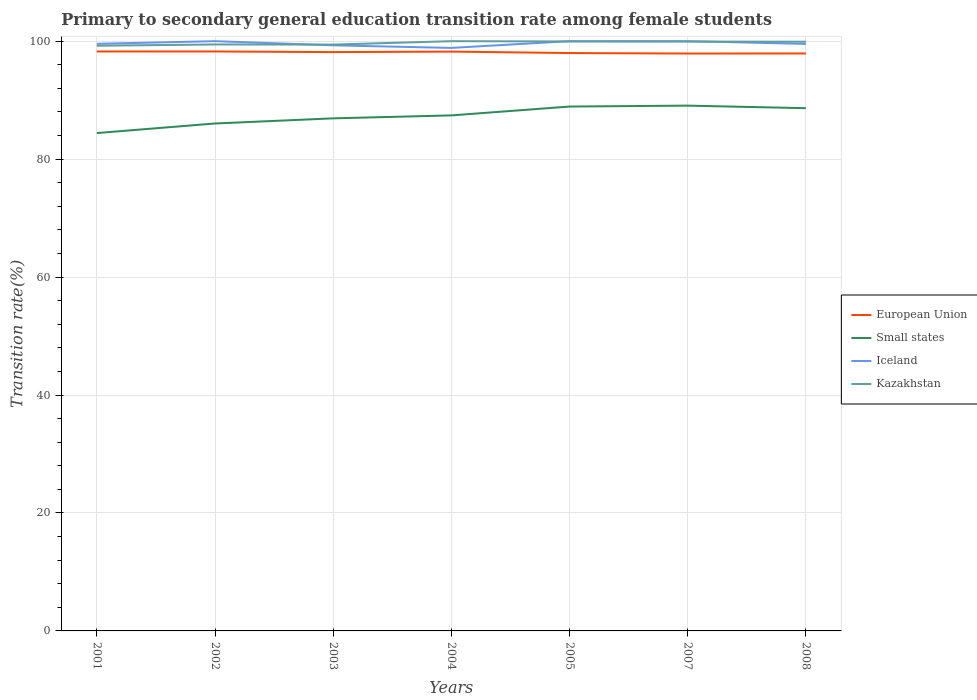How many different coloured lines are there?
Provide a succinct answer. 4. Does the line corresponding to Iceland intersect with the line corresponding to Small states?
Your answer should be very brief. No. Is the number of lines equal to the number of legend labels?
Provide a short and direct response. Yes. Across all years, what is the maximum transition rate in Kazakhstan?
Your answer should be compact. 99.23. In which year was the transition rate in Small states maximum?
Make the answer very short. 2001. What is the total transition rate in European Union in the graph?
Keep it short and to the point. 0.02. What is the difference between the highest and the second highest transition rate in European Union?
Keep it short and to the point. 0.35. What is the difference between the highest and the lowest transition rate in Iceland?
Give a very brief answer. 3. Are the values on the major ticks of Y-axis written in scientific E-notation?
Your response must be concise. No. Does the graph contain any zero values?
Offer a very short reply. No. Does the graph contain grids?
Give a very brief answer. Yes. How many legend labels are there?
Your response must be concise. 4. How are the legend labels stacked?
Provide a succinct answer. Vertical. What is the title of the graph?
Give a very brief answer. Primary to secondary general education transition rate among female students. Does "Palau" appear as one of the legend labels in the graph?
Your answer should be very brief. No. What is the label or title of the Y-axis?
Your response must be concise. Transition rate(%). What is the Transition rate(%) of European Union in 2001?
Provide a succinct answer. 98.25. What is the Transition rate(%) of Small states in 2001?
Keep it short and to the point. 84.42. What is the Transition rate(%) in Iceland in 2001?
Give a very brief answer. 99.55. What is the Transition rate(%) of Kazakhstan in 2001?
Give a very brief answer. 99.23. What is the Transition rate(%) of European Union in 2002?
Offer a terse response. 98.26. What is the Transition rate(%) of Small states in 2002?
Give a very brief answer. 86.04. What is the Transition rate(%) in Iceland in 2002?
Your answer should be very brief. 100. What is the Transition rate(%) in Kazakhstan in 2002?
Offer a very short reply. 99.44. What is the Transition rate(%) in European Union in 2003?
Give a very brief answer. 98.15. What is the Transition rate(%) of Small states in 2003?
Ensure brevity in your answer.  86.92. What is the Transition rate(%) in Iceland in 2003?
Offer a terse response. 99.29. What is the Transition rate(%) in Kazakhstan in 2003?
Your answer should be very brief. 99.42. What is the Transition rate(%) of European Union in 2004?
Ensure brevity in your answer.  98.23. What is the Transition rate(%) of Small states in 2004?
Keep it short and to the point. 87.41. What is the Transition rate(%) of Iceland in 2004?
Your answer should be very brief. 98.86. What is the Transition rate(%) in European Union in 2005?
Give a very brief answer. 97.99. What is the Transition rate(%) in Small states in 2005?
Offer a very short reply. 88.91. What is the Transition rate(%) of Iceland in 2005?
Make the answer very short. 100. What is the Transition rate(%) of Kazakhstan in 2005?
Give a very brief answer. 99.95. What is the Transition rate(%) in European Union in 2007?
Your answer should be very brief. 97.9. What is the Transition rate(%) in Small states in 2007?
Provide a succinct answer. 89.07. What is the Transition rate(%) in Iceland in 2007?
Offer a very short reply. 100. What is the Transition rate(%) in Kazakhstan in 2007?
Make the answer very short. 99.93. What is the Transition rate(%) in European Union in 2008?
Make the answer very short. 97.92. What is the Transition rate(%) in Small states in 2008?
Offer a very short reply. 88.64. What is the Transition rate(%) of Iceland in 2008?
Offer a terse response. 99.54. What is the Transition rate(%) of Kazakhstan in 2008?
Give a very brief answer. 99.91. Across all years, what is the maximum Transition rate(%) in European Union?
Give a very brief answer. 98.26. Across all years, what is the maximum Transition rate(%) in Small states?
Provide a succinct answer. 89.07. Across all years, what is the maximum Transition rate(%) in Kazakhstan?
Your answer should be compact. 100. Across all years, what is the minimum Transition rate(%) of European Union?
Keep it short and to the point. 97.9. Across all years, what is the minimum Transition rate(%) of Small states?
Make the answer very short. 84.42. Across all years, what is the minimum Transition rate(%) of Iceland?
Make the answer very short. 98.86. Across all years, what is the minimum Transition rate(%) of Kazakhstan?
Offer a terse response. 99.23. What is the total Transition rate(%) of European Union in the graph?
Provide a short and direct response. 686.69. What is the total Transition rate(%) of Small states in the graph?
Keep it short and to the point. 611.41. What is the total Transition rate(%) of Iceland in the graph?
Provide a short and direct response. 697.24. What is the total Transition rate(%) in Kazakhstan in the graph?
Your answer should be very brief. 697.88. What is the difference between the Transition rate(%) in European Union in 2001 and that in 2002?
Your answer should be compact. -0. What is the difference between the Transition rate(%) in Small states in 2001 and that in 2002?
Provide a succinct answer. -1.62. What is the difference between the Transition rate(%) of Iceland in 2001 and that in 2002?
Keep it short and to the point. -0.45. What is the difference between the Transition rate(%) of Kazakhstan in 2001 and that in 2002?
Provide a short and direct response. -0.21. What is the difference between the Transition rate(%) in European Union in 2001 and that in 2003?
Ensure brevity in your answer.  0.11. What is the difference between the Transition rate(%) in Small states in 2001 and that in 2003?
Make the answer very short. -2.5. What is the difference between the Transition rate(%) in Iceland in 2001 and that in 2003?
Your answer should be compact. 0.25. What is the difference between the Transition rate(%) in Kazakhstan in 2001 and that in 2003?
Provide a succinct answer. -0.19. What is the difference between the Transition rate(%) of European Union in 2001 and that in 2004?
Your response must be concise. 0.02. What is the difference between the Transition rate(%) of Small states in 2001 and that in 2004?
Make the answer very short. -2.99. What is the difference between the Transition rate(%) of Iceland in 2001 and that in 2004?
Your response must be concise. 0.69. What is the difference between the Transition rate(%) in Kazakhstan in 2001 and that in 2004?
Provide a short and direct response. -0.77. What is the difference between the Transition rate(%) in European Union in 2001 and that in 2005?
Your answer should be very brief. 0.27. What is the difference between the Transition rate(%) of Small states in 2001 and that in 2005?
Your answer should be compact. -4.5. What is the difference between the Transition rate(%) in Iceland in 2001 and that in 2005?
Ensure brevity in your answer.  -0.45. What is the difference between the Transition rate(%) of Kazakhstan in 2001 and that in 2005?
Your answer should be very brief. -0.72. What is the difference between the Transition rate(%) in European Union in 2001 and that in 2007?
Keep it short and to the point. 0.35. What is the difference between the Transition rate(%) of Small states in 2001 and that in 2007?
Your answer should be very brief. -4.65. What is the difference between the Transition rate(%) in Iceland in 2001 and that in 2007?
Your response must be concise. -0.45. What is the difference between the Transition rate(%) in Kazakhstan in 2001 and that in 2007?
Give a very brief answer. -0.7. What is the difference between the Transition rate(%) in European Union in 2001 and that in 2008?
Offer a very short reply. 0.34. What is the difference between the Transition rate(%) in Small states in 2001 and that in 2008?
Make the answer very short. -4.22. What is the difference between the Transition rate(%) of Iceland in 2001 and that in 2008?
Give a very brief answer. 0.01. What is the difference between the Transition rate(%) of Kazakhstan in 2001 and that in 2008?
Your answer should be very brief. -0.68. What is the difference between the Transition rate(%) of European Union in 2002 and that in 2003?
Provide a short and direct response. 0.11. What is the difference between the Transition rate(%) of Small states in 2002 and that in 2003?
Give a very brief answer. -0.87. What is the difference between the Transition rate(%) in Iceland in 2002 and that in 2003?
Make the answer very short. 0.71. What is the difference between the Transition rate(%) of Kazakhstan in 2002 and that in 2003?
Your answer should be very brief. 0.02. What is the difference between the Transition rate(%) of European Union in 2002 and that in 2004?
Provide a short and direct response. 0.02. What is the difference between the Transition rate(%) in Small states in 2002 and that in 2004?
Offer a very short reply. -1.37. What is the difference between the Transition rate(%) of Iceland in 2002 and that in 2004?
Keep it short and to the point. 1.14. What is the difference between the Transition rate(%) of Kazakhstan in 2002 and that in 2004?
Your answer should be very brief. -0.56. What is the difference between the Transition rate(%) in European Union in 2002 and that in 2005?
Provide a short and direct response. 0.27. What is the difference between the Transition rate(%) in Small states in 2002 and that in 2005?
Provide a short and direct response. -2.87. What is the difference between the Transition rate(%) of Iceland in 2002 and that in 2005?
Your answer should be compact. 0. What is the difference between the Transition rate(%) of Kazakhstan in 2002 and that in 2005?
Keep it short and to the point. -0.51. What is the difference between the Transition rate(%) of European Union in 2002 and that in 2007?
Your answer should be compact. 0.35. What is the difference between the Transition rate(%) in Small states in 2002 and that in 2007?
Give a very brief answer. -3.03. What is the difference between the Transition rate(%) in Kazakhstan in 2002 and that in 2007?
Provide a succinct answer. -0.49. What is the difference between the Transition rate(%) of European Union in 2002 and that in 2008?
Offer a terse response. 0.34. What is the difference between the Transition rate(%) of Small states in 2002 and that in 2008?
Keep it short and to the point. -2.59. What is the difference between the Transition rate(%) of Iceland in 2002 and that in 2008?
Offer a terse response. 0.46. What is the difference between the Transition rate(%) of Kazakhstan in 2002 and that in 2008?
Your answer should be compact. -0.47. What is the difference between the Transition rate(%) in European Union in 2003 and that in 2004?
Your response must be concise. -0.09. What is the difference between the Transition rate(%) in Small states in 2003 and that in 2004?
Your answer should be compact. -0.5. What is the difference between the Transition rate(%) of Iceland in 2003 and that in 2004?
Give a very brief answer. 0.44. What is the difference between the Transition rate(%) of Kazakhstan in 2003 and that in 2004?
Your answer should be very brief. -0.58. What is the difference between the Transition rate(%) of European Union in 2003 and that in 2005?
Keep it short and to the point. 0.16. What is the difference between the Transition rate(%) in Small states in 2003 and that in 2005?
Give a very brief answer. -2. What is the difference between the Transition rate(%) in Iceland in 2003 and that in 2005?
Offer a very short reply. -0.71. What is the difference between the Transition rate(%) of Kazakhstan in 2003 and that in 2005?
Offer a terse response. -0.53. What is the difference between the Transition rate(%) in European Union in 2003 and that in 2007?
Provide a succinct answer. 0.24. What is the difference between the Transition rate(%) in Small states in 2003 and that in 2007?
Your answer should be compact. -2.16. What is the difference between the Transition rate(%) in Iceland in 2003 and that in 2007?
Provide a succinct answer. -0.71. What is the difference between the Transition rate(%) in Kazakhstan in 2003 and that in 2007?
Offer a terse response. -0.51. What is the difference between the Transition rate(%) of European Union in 2003 and that in 2008?
Ensure brevity in your answer.  0.23. What is the difference between the Transition rate(%) in Small states in 2003 and that in 2008?
Ensure brevity in your answer.  -1.72. What is the difference between the Transition rate(%) of Iceland in 2003 and that in 2008?
Your answer should be very brief. -0.24. What is the difference between the Transition rate(%) of Kazakhstan in 2003 and that in 2008?
Your response must be concise. -0.49. What is the difference between the Transition rate(%) in European Union in 2004 and that in 2005?
Offer a terse response. 0.25. What is the difference between the Transition rate(%) in Small states in 2004 and that in 2005?
Offer a very short reply. -1.5. What is the difference between the Transition rate(%) of Iceland in 2004 and that in 2005?
Your answer should be compact. -1.14. What is the difference between the Transition rate(%) of Kazakhstan in 2004 and that in 2005?
Offer a terse response. 0.05. What is the difference between the Transition rate(%) in European Union in 2004 and that in 2007?
Offer a terse response. 0.33. What is the difference between the Transition rate(%) of Small states in 2004 and that in 2007?
Keep it short and to the point. -1.66. What is the difference between the Transition rate(%) of Iceland in 2004 and that in 2007?
Give a very brief answer. -1.14. What is the difference between the Transition rate(%) in Kazakhstan in 2004 and that in 2007?
Provide a succinct answer. 0.07. What is the difference between the Transition rate(%) in European Union in 2004 and that in 2008?
Provide a short and direct response. 0.32. What is the difference between the Transition rate(%) of Small states in 2004 and that in 2008?
Provide a short and direct response. -1.22. What is the difference between the Transition rate(%) in Iceland in 2004 and that in 2008?
Give a very brief answer. -0.68. What is the difference between the Transition rate(%) in Kazakhstan in 2004 and that in 2008?
Provide a succinct answer. 0.09. What is the difference between the Transition rate(%) in European Union in 2005 and that in 2007?
Offer a terse response. 0.08. What is the difference between the Transition rate(%) in Small states in 2005 and that in 2007?
Your response must be concise. -0.16. What is the difference between the Transition rate(%) of Iceland in 2005 and that in 2007?
Your response must be concise. 0. What is the difference between the Transition rate(%) in Kazakhstan in 2005 and that in 2007?
Ensure brevity in your answer.  0.02. What is the difference between the Transition rate(%) in European Union in 2005 and that in 2008?
Give a very brief answer. 0.07. What is the difference between the Transition rate(%) in Small states in 2005 and that in 2008?
Offer a very short reply. 0.28. What is the difference between the Transition rate(%) in Iceland in 2005 and that in 2008?
Your answer should be compact. 0.46. What is the difference between the Transition rate(%) in Kazakhstan in 2005 and that in 2008?
Offer a very short reply. 0.05. What is the difference between the Transition rate(%) in European Union in 2007 and that in 2008?
Your answer should be very brief. -0.01. What is the difference between the Transition rate(%) of Small states in 2007 and that in 2008?
Your response must be concise. 0.43. What is the difference between the Transition rate(%) in Iceland in 2007 and that in 2008?
Your answer should be very brief. 0.46. What is the difference between the Transition rate(%) of Kazakhstan in 2007 and that in 2008?
Keep it short and to the point. 0.03. What is the difference between the Transition rate(%) in European Union in 2001 and the Transition rate(%) in Small states in 2002?
Provide a short and direct response. 12.21. What is the difference between the Transition rate(%) in European Union in 2001 and the Transition rate(%) in Iceland in 2002?
Your answer should be very brief. -1.75. What is the difference between the Transition rate(%) in European Union in 2001 and the Transition rate(%) in Kazakhstan in 2002?
Provide a succinct answer. -1.19. What is the difference between the Transition rate(%) in Small states in 2001 and the Transition rate(%) in Iceland in 2002?
Give a very brief answer. -15.58. What is the difference between the Transition rate(%) in Small states in 2001 and the Transition rate(%) in Kazakhstan in 2002?
Your answer should be compact. -15.02. What is the difference between the Transition rate(%) in Iceland in 2001 and the Transition rate(%) in Kazakhstan in 2002?
Ensure brevity in your answer.  0.11. What is the difference between the Transition rate(%) of European Union in 2001 and the Transition rate(%) of Small states in 2003?
Provide a succinct answer. 11.34. What is the difference between the Transition rate(%) in European Union in 2001 and the Transition rate(%) in Iceland in 2003?
Your answer should be compact. -1.04. What is the difference between the Transition rate(%) in European Union in 2001 and the Transition rate(%) in Kazakhstan in 2003?
Offer a terse response. -1.17. What is the difference between the Transition rate(%) in Small states in 2001 and the Transition rate(%) in Iceland in 2003?
Ensure brevity in your answer.  -14.88. What is the difference between the Transition rate(%) in Small states in 2001 and the Transition rate(%) in Kazakhstan in 2003?
Provide a succinct answer. -15. What is the difference between the Transition rate(%) in Iceland in 2001 and the Transition rate(%) in Kazakhstan in 2003?
Make the answer very short. 0.13. What is the difference between the Transition rate(%) in European Union in 2001 and the Transition rate(%) in Small states in 2004?
Your answer should be very brief. 10.84. What is the difference between the Transition rate(%) in European Union in 2001 and the Transition rate(%) in Iceland in 2004?
Give a very brief answer. -0.6. What is the difference between the Transition rate(%) in European Union in 2001 and the Transition rate(%) in Kazakhstan in 2004?
Give a very brief answer. -1.75. What is the difference between the Transition rate(%) of Small states in 2001 and the Transition rate(%) of Iceland in 2004?
Your response must be concise. -14.44. What is the difference between the Transition rate(%) in Small states in 2001 and the Transition rate(%) in Kazakhstan in 2004?
Offer a terse response. -15.58. What is the difference between the Transition rate(%) of Iceland in 2001 and the Transition rate(%) of Kazakhstan in 2004?
Your answer should be very brief. -0.45. What is the difference between the Transition rate(%) of European Union in 2001 and the Transition rate(%) of Small states in 2005?
Your response must be concise. 9.34. What is the difference between the Transition rate(%) in European Union in 2001 and the Transition rate(%) in Iceland in 2005?
Provide a succinct answer. -1.75. What is the difference between the Transition rate(%) in European Union in 2001 and the Transition rate(%) in Kazakhstan in 2005?
Your answer should be very brief. -1.7. What is the difference between the Transition rate(%) in Small states in 2001 and the Transition rate(%) in Iceland in 2005?
Offer a terse response. -15.58. What is the difference between the Transition rate(%) of Small states in 2001 and the Transition rate(%) of Kazakhstan in 2005?
Your answer should be very brief. -15.53. What is the difference between the Transition rate(%) of Iceland in 2001 and the Transition rate(%) of Kazakhstan in 2005?
Ensure brevity in your answer.  -0.4. What is the difference between the Transition rate(%) in European Union in 2001 and the Transition rate(%) in Small states in 2007?
Offer a very short reply. 9.18. What is the difference between the Transition rate(%) of European Union in 2001 and the Transition rate(%) of Iceland in 2007?
Your answer should be very brief. -1.75. What is the difference between the Transition rate(%) in European Union in 2001 and the Transition rate(%) in Kazakhstan in 2007?
Ensure brevity in your answer.  -1.68. What is the difference between the Transition rate(%) in Small states in 2001 and the Transition rate(%) in Iceland in 2007?
Your answer should be compact. -15.58. What is the difference between the Transition rate(%) in Small states in 2001 and the Transition rate(%) in Kazakhstan in 2007?
Offer a very short reply. -15.51. What is the difference between the Transition rate(%) of Iceland in 2001 and the Transition rate(%) of Kazakhstan in 2007?
Your answer should be very brief. -0.38. What is the difference between the Transition rate(%) of European Union in 2001 and the Transition rate(%) of Small states in 2008?
Offer a very short reply. 9.62. What is the difference between the Transition rate(%) in European Union in 2001 and the Transition rate(%) in Iceland in 2008?
Provide a succinct answer. -1.29. What is the difference between the Transition rate(%) of European Union in 2001 and the Transition rate(%) of Kazakhstan in 2008?
Provide a short and direct response. -1.65. What is the difference between the Transition rate(%) in Small states in 2001 and the Transition rate(%) in Iceland in 2008?
Give a very brief answer. -15.12. What is the difference between the Transition rate(%) of Small states in 2001 and the Transition rate(%) of Kazakhstan in 2008?
Offer a terse response. -15.49. What is the difference between the Transition rate(%) of Iceland in 2001 and the Transition rate(%) of Kazakhstan in 2008?
Provide a succinct answer. -0.36. What is the difference between the Transition rate(%) in European Union in 2002 and the Transition rate(%) in Small states in 2003?
Make the answer very short. 11.34. What is the difference between the Transition rate(%) of European Union in 2002 and the Transition rate(%) of Iceland in 2003?
Keep it short and to the point. -1.04. What is the difference between the Transition rate(%) in European Union in 2002 and the Transition rate(%) in Kazakhstan in 2003?
Your answer should be very brief. -1.17. What is the difference between the Transition rate(%) of Small states in 2002 and the Transition rate(%) of Iceland in 2003?
Provide a succinct answer. -13.25. What is the difference between the Transition rate(%) in Small states in 2002 and the Transition rate(%) in Kazakhstan in 2003?
Offer a very short reply. -13.38. What is the difference between the Transition rate(%) in Iceland in 2002 and the Transition rate(%) in Kazakhstan in 2003?
Your answer should be very brief. 0.58. What is the difference between the Transition rate(%) of European Union in 2002 and the Transition rate(%) of Small states in 2004?
Offer a terse response. 10.84. What is the difference between the Transition rate(%) of European Union in 2002 and the Transition rate(%) of Iceland in 2004?
Ensure brevity in your answer.  -0.6. What is the difference between the Transition rate(%) in European Union in 2002 and the Transition rate(%) in Kazakhstan in 2004?
Your answer should be compact. -1.74. What is the difference between the Transition rate(%) of Small states in 2002 and the Transition rate(%) of Iceland in 2004?
Give a very brief answer. -12.81. What is the difference between the Transition rate(%) of Small states in 2002 and the Transition rate(%) of Kazakhstan in 2004?
Your answer should be compact. -13.96. What is the difference between the Transition rate(%) of European Union in 2002 and the Transition rate(%) of Small states in 2005?
Your answer should be compact. 9.34. What is the difference between the Transition rate(%) in European Union in 2002 and the Transition rate(%) in Iceland in 2005?
Provide a short and direct response. -1.74. What is the difference between the Transition rate(%) of European Union in 2002 and the Transition rate(%) of Kazakhstan in 2005?
Keep it short and to the point. -1.7. What is the difference between the Transition rate(%) of Small states in 2002 and the Transition rate(%) of Iceland in 2005?
Your response must be concise. -13.96. What is the difference between the Transition rate(%) of Small states in 2002 and the Transition rate(%) of Kazakhstan in 2005?
Offer a terse response. -13.91. What is the difference between the Transition rate(%) of Iceland in 2002 and the Transition rate(%) of Kazakhstan in 2005?
Make the answer very short. 0.05. What is the difference between the Transition rate(%) of European Union in 2002 and the Transition rate(%) of Small states in 2007?
Your answer should be very brief. 9.18. What is the difference between the Transition rate(%) in European Union in 2002 and the Transition rate(%) in Iceland in 2007?
Your answer should be compact. -1.74. What is the difference between the Transition rate(%) in European Union in 2002 and the Transition rate(%) in Kazakhstan in 2007?
Provide a short and direct response. -1.68. What is the difference between the Transition rate(%) of Small states in 2002 and the Transition rate(%) of Iceland in 2007?
Give a very brief answer. -13.96. What is the difference between the Transition rate(%) of Small states in 2002 and the Transition rate(%) of Kazakhstan in 2007?
Make the answer very short. -13.89. What is the difference between the Transition rate(%) of Iceland in 2002 and the Transition rate(%) of Kazakhstan in 2007?
Your response must be concise. 0.07. What is the difference between the Transition rate(%) in European Union in 2002 and the Transition rate(%) in Small states in 2008?
Give a very brief answer. 9.62. What is the difference between the Transition rate(%) of European Union in 2002 and the Transition rate(%) of Iceland in 2008?
Offer a very short reply. -1.28. What is the difference between the Transition rate(%) of European Union in 2002 and the Transition rate(%) of Kazakhstan in 2008?
Offer a very short reply. -1.65. What is the difference between the Transition rate(%) in Small states in 2002 and the Transition rate(%) in Iceland in 2008?
Provide a short and direct response. -13.5. What is the difference between the Transition rate(%) of Small states in 2002 and the Transition rate(%) of Kazakhstan in 2008?
Offer a very short reply. -13.86. What is the difference between the Transition rate(%) in Iceland in 2002 and the Transition rate(%) in Kazakhstan in 2008?
Ensure brevity in your answer.  0.09. What is the difference between the Transition rate(%) of European Union in 2003 and the Transition rate(%) of Small states in 2004?
Give a very brief answer. 10.73. What is the difference between the Transition rate(%) in European Union in 2003 and the Transition rate(%) in Iceland in 2004?
Offer a very short reply. -0.71. What is the difference between the Transition rate(%) in European Union in 2003 and the Transition rate(%) in Kazakhstan in 2004?
Offer a very short reply. -1.85. What is the difference between the Transition rate(%) in Small states in 2003 and the Transition rate(%) in Iceland in 2004?
Your response must be concise. -11.94. What is the difference between the Transition rate(%) in Small states in 2003 and the Transition rate(%) in Kazakhstan in 2004?
Provide a succinct answer. -13.08. What is the difference between the Transition rate(%) in Iceland in 2003 and the Transition rate(%) in Kazakhstan in 2004?
Your answer should be very brief. -0.71. What is the difference between the Transition rate(%) of European Union in 2003 and the Transition rate(%) of Small states in 2005?
Give a very brief answer. 9.23. What is the difference between the Transition rate(%) of European Union in 2003 and the Transition rate(%) of Iceland in 2005?
Make the answer very short. -1.85. What is the difference between the Transition rate(%) of European Union in 2003 and the Transition rate(%) of Kazakhstan in 2005?
Your answer should be very brief. -1.81. What is the difference between the Transition rate(%) in Small states in 2003 and the Transition rate(%) in Iceland in 2005?
Keep it short and to the point. -13.08. What is the difference between the Transition rate(%) of Small states in 2003 and the Transition rate(%) of Kazakhstan in 2005?
Your response must be concise. -13.04. What is the difference between the Transition rate(%) of Iceland in 2003 and the Transition rate(%) of Kazakhstan in 2005?
Provide a succinct answer. -0.66. What is the difference between the Transition rate(%) of European Union in 2003 and the Transition rate(%) of Small states in 2007?
Your answer should be very brief. 9.08. What is the difference between the Transition rate(%) in European Union in 2003 and the Transition rate(%) in Iceland in 2007?
Provide a succinct answer. -1.85. What is the difference between the Transition rate(%) of European Union in 2003 and the Transition rate(%) of Kazakhstan in 2007?
Keep it short and to the point. -1.79. What is the difference between the Transition rate(%) in Small states in 2003 and the Transition rate(%) in Iceland in 2007?
Make the answer very short. -13.08. What is the difference between the Transition rate(%) in Small states in 2003 and the Transition rate(%) in Kazakhstan in 2007?
Your answer should be compact. -13.02. What is the difference between the Transition rate(%) in Iceland in 2003 and the Transition rate(%) in Kazakhstan in 2007?
Provide a short and direct response. -0.64. What is the difference between the Transition rate(%) in European Union in 2003 and the Transition rate(%) in Small states in 2008?
Offer a terse response. 9.51. What is the difference between the Transition rate(%) in European Union in 2003 and the Transition rate(%) in Iceland in 2008?
Provide a short and direct response. -1.39. What is the difference between the Transition rate(%) of European Union in 2003 and the Transition rate(%) of Kazakhstan in 2008?
Provide a succinct answer. -1.76. What is the difference between the Transition rate(%) of Small states in 2003 and the Transition rate(%) of Iceland in 2008?
Offer a terse response. -12.62. What is the difference between the Transition rate(%) in Small states in 2003 and the Transition rate(%) in Kazakhstan in 2008?
Make the answer very short. -12.99. What is the difference between the Transition rate(%) in Iceland in 2003 and the Transition rate(%) in Kazakhstan in 2008?
Ensure brevity in your answer.  -0.61. What is the difference between the Transition rate(%) in European Union in 2004 and the Transition rate(%) in Small states in 2005?
Give a very brief answer. 9.32. What is the difference between the Transition rate(%) of European Union in 2004 and the Transition rate(%) of Iceland in 2005?
Keep it short and to the point. -1.77. What is the difference between the Transition rate(%) of European Union in 2004 and the Transition rate(%) of Kazakhstan in 2005?
Ensure brevity in your answer.  -1.72. What is the difference between the Transition rate(%) in Small states in 2004 and the Transition rate(%) in Iceland in 2005?
Your response must be concise. -12.59. What is the difference between the Transition rate(%) of Small states in 2004 and the Transition rate(%) of Kazakhstan in 2005?
Your response must be concise. -12.54. What is the difference between the Transition rate(%) in Iceland in 2004 and the Transition rate(%) in Kazakhstan in 2005?
Your response must be concise. -1.09. What is the difference between the Transition rate(%) of European Union in 2004 and the Transition rate(%) of Small states in 2007?
Your response must be concise. 9.16. What is the difference between the Transition rate(%) of European Union in 2004 and the Transition rate(%) of Iceland in 2007?
Offer a terse response. -1.77. What is the difference between the Transition rate(%) in European Union in 2004 and the Transition rate(%) in Kazakhstan in 2007?
Keep it short and to the point. -1.7. What is the difference between the Transition rate(%) of Small states in 2004 and the Transition rate(%) of Iceland in 2007?
Make the answer very short. -12.59. What is the difference between the Transition rate(%) in Small states in 2004 and the Transition rate(%) in Kazakhstan in 2007?
Your answer should be compact. -12.52. What is the difference between the Transition rate(%) of Iceland in 2004 and the Transition rate(%) of Kazakhstan in 2007?
Provide a succinct answer. -1.07. What is the difference between the Transition rate(%) of European Union in 2004 and the Transition rate(%) of Small states in 2008?
Your answer should be very brief. 9.59. What is the difference between the Transition rate(%) of European Union in 2004 and the Transition rate(%) of Iceland in 2008?
Provide a succinct answer. -1.31. What is the difference between the Transition rate(%) in European Union in 2004 and the Transition rate(%) in Kazakhstan in 2008?
Offer a terse response. -1.68. What is the difference between the Transition rate(%) of Small states in 2004 and the Transition rate(%) of Iceland in 2008?
Provide a succinct answer. -12.13. What is the difference between the Transition rate(%) of Small states in 2004 and the Transition rate(%) of Kazakhstan in 2008?
Offer a very short reply. -12.49. What is the difference between the Transition rate(%) of Iceland in 2004 and the Transition rate(%) of Kazakhstan in 2008?
Keep it short and to the point. -1.05. What is the difference between the Transition rate(%) in European Union in 2005 and the Transition rate(%) in Small states in 2007?
Provide a short and direct response. 8.91. What is the difference between the Transition rate(%) in European Union in 2005 and the Transition rate(%) in Iceland in 2007?
Your answer should be compact. -2.01. What is the difference between the Transition rate(%) of European Union in 2005 and the Transition rate(%) of Kazakhstan in 2007?
Keep it short and to the point. -1.95. What is the difference between the Transition rate(%) of Small states in 2005 and the Transition rate(%) of Iceland in 2007?
Offer a terse response. -11.09. What is the difference between the Transition rate(%) in Small states in 2005 and the Transition rate(%) in Kazakhstan in 2007?
Ensure brevity in your answer.  -11.02. What is the difference between the Transition rate(%) in Iceland in 2005 and the Transition rate(%) in Kazakhstan in 2007?
Keep it short and to the point. 0.07. What is the difference between the Transition rate(%) of European Union in 2005 and the Transition rate(%) of Small states in 2008?
Offer a terse response. 9.35. What is the difference between the Transition rate(%) of European Union in 2005 and the Transition rate(%) of Iceland in 2008?
Your response must be concise. -1.55. What is the difference between the Transition rate(%) of European Union in 2005 and the Transition rate(%) of Kazakhstan in 2008?
Your response must be concise. -1.92. What is the difference between the Transition rate(%) of Small states in 2005 and the Transition rate(%) of Iceland in 2008?
Your response must be concise. -10.62. What is the difference between the Transition rate(%) in Small states in 2005 and the Transition rate(%) in Kazakhstan in 2008?
Keep it short and to the point. -10.99. What is the difference between the Transition rate(%) of Iceland in 2005 and the Transition rate(%) of Kazakhstan in 2008?
Your answer should be very brief. 0.09. What is the difference between the Transition rate(%) in European Union in 2007 and the Transition rate(%) in Small states in 2008?
Keep it short and to the point. 9.27. What is the difference between the Transition rate(%) in European Union in 2007 and the Transition rate(%) in Iceland in 2008?
Keep it short and to the point. -1.64. What is the difference between the Transition rate(%) of European Union in 2007 and the Transition rate(%) of Kazakhstan in 2008?
Make the answer very short. -2. What is the difference between the Transition rate(%) of Small states in 2007 and the Transition rate(%) of Iceland in 2008?
Offer a terse response. -10.47. What is the difference between the Transition rate(%) of Small states in 2007 and the Transition rate(%) of Kazakhstan in 2008?
Offer a very short reply. -10.84. What is the difference between the Transition rate(%) in Iceland in 2007 and the Transition rate(%) in Kazakhstan in 2008?
Ensure brevity in your answer.  0.09. What is the average Transition rate(%) in European Union per year?
Offer a terse response. 98.1. What is the average Transition rate(%) in Small states per year?
Provide a succinct answer. 87.34. What is the average Transition rate(%) of Iceland per year?
Provide a short and direct response. 99.61. What is the average Transition rate(%) in Kazakhstan per year?
Your answer should be very brief. 99.7. In the year 2001, what is the difference between the Transition rate(%) in European Union and Transition rate(%) in Small states?
Give a very brief answer. 13.84. In the year 2001, what is the difference between the Transition rate(%) of European Union and Transition rate(%) of Iceland?
Provide a short and direct response. -1.29. In the year 2001, what is the difference between the Transition rate(%) of European Union and Transition rate(%) of Kazakhstan?
Provide a succinct answer. -0.98. In the year 2001, what is the difference between the Transition rate(%) in Small states and Transition rate(%) in Iceland?
Ensure brevity in your answer.  -15.13. In the year 2001, what is the difference between the Transition rate(%) in Small states and Transition rate(%) in Kazakhstan?
Make the answer very short. -14.81. In the year 2001, what is the difference between the Transition rate(%) of Iceland and Transition rate(%) of Kazakhstan?
Provide a short and direct response. 0.32. In the year 2002, what is the difference between the Transition rate(%) of European Union and Transition rate(%) of Small states?
Your response must be concise. 12.21. In the year 2002, what is the difference between the Transition rate(%) of European Union and Transition rate(%) of Iceland?
Offer a terse response. -1.74. In the year 2002, what is the difference between the Transition rate(%) in European Union and Transition rate(%) in Kazakhstan?
Offer a terse response. -1.19. In the year 2002, what is the difference between the Transition rate(%) of Small states and Transition rate(%) of Iceland?
Provide a short and direct response. -13.96. In the year 2002, what is the difference between the Transition rate(%) in Small states and Transition rate(%) in Kazakhstan?
Your answer should be very brief. -13.4. In the year 2002, what is the difference between the Transition rate(%) of Iceland and Transition rate(%) of Kazakhstan?
Offer a very short reply. 0.56. In the year 2003, what is the difference between the Transition rate(%) in European Union and Transition rate(%) in Small states?
Provide a succinct answer. 11.23. In the year 2003, what is the difference between the Transition rate(%) in European Union and Transition rate(%) in Iceland?
Keep it short and to the point. -1.15. In the year 2003, what is the difference between the Transition rate(%) of European Union and Transition rate(%) of Kazakhstan?
Your response must be concise. -1.27. In the year 2003, what is the difference between the Transition rate(%) of Small states and Transition rate(%) of Iceland?
Your answer should be compact. -12.38. In the year 2003, what is the difference between the Transition rate(%) in Small states and Transition rate(%) in Kazakhstan?
Provide a succinct answer. -12.51. In the year 2003, what is the difference between the Transition rate(%) of Iceland and Transition rate(%) of Kazakhstan?
Your answer should be compact. -0.13. In the year 2004, what is the difference between the Transition rate(%) of European Union and Transition rate(%) of Small states?
Give a very brief answer. 10.82. In the year 2004, what is the difference between the Transition rate(%) in European Union and Transition rate(%) in Iceland?
Your response must be concise. -0.63. In the year 2004, what is the difference between the Transition rate(%) of European Union and Transition rate(%) of Kazakhstan?
Your answer should be compact. -1.77. In the year 2004, what is the difference between the Transition rate(%) of Small states and Transition rate(%) of Iceland?
Provide a succinct answer. -11.45. In the year 2004, what is the difference between the Transition rate(%) of Small states and Transition rate(%) of Kazakhstan?
Ensure brevity in your answer.  -12.59. In the year 2004, what is the difference between the Transition rate(%) of Iceland and Transition rate(%) of Kazakhstan?
Offer a very short reply. -1.14. In the year 2005, what is the difference between the Transition rate(%) of European Union and Transition rate(%) of Small states?
Keep it short and to the point. 9.07. In the year 2005, what is the difference between the Transition rate(%) in European Union and Transition rate(%) in Iceland?
Offer a very short reply. -2.01. In the year 2005, what is the difference between the Transition rate(%) in European Union and Transition rate(%) in Kazakhstan?
Your response must be concise. -1.97. In the year 2005, what is the difference between the Transition rate(%) in Small states and Transition rate(%) in Iceland?
Your answer should be very brief. -11.09. In the year 2005, what is the difference between the Transition rate(%) in Small states and Transition rate(%) in Kazakhstan?
Your response must be concise. -11.04. In the year 2005, what is the difference between the Transition rate(%) of Iceland and Transition rate(%) of Kazakhstan?
Provide a succinct answer. 0.05. In the year 2007, what is the difference between the Transition rate(%) of European Union and Transition rate(%) of Small states?
Offer a terse response. 8.83. In the year 2007, what is the difference between the Transition rate(%) in European Union and Transition rate(%) in Iceland?
Provide a succinct answer. -2.1. In the year 2007, what is the difference between the Transition rate(%) in European Union and Transition rate(%) in Kazakhstan?
Keep it short and to the point. -2.03. In the year 2007, what is the difference between the Transition rate(%) of Small states and Transition rate(%) of Iceland?
Make the answer very short. -10.93. In the year 2007, what is the difference between the Transition rate(%) in Small states and Transition rate(%) in Kazakhstan?
Give a very brief answer. -10.86. In the year 2007, what is the difference between the Transition rate(%) of Iceland and Transition rate(%) of Kazakhstan?
Make the answer very short. 0.07. In the year 2008, what is the difference between the Transition rate(%) of European Union and Transition rate(%) of Small states?
Your response must be concise. 9.28. In the year 2008, what is the difference between the Transition rate(%) of European Union and Transition rate(%) of Iceland?
Offer a terse response. -1.62. In the year 2008, what is the difference between the Transition rate(%) in European Union and Transition rate(%) in Kazakhstan?
Give a very brief answer. -1.99. In the year 2008, what is the difference between the Transition rate(%) of Small states and Transition rate(%) of Iceland?
Offer a very short reply. -10.9. In the year 2008, what is the difference between the Transition rate(%) of Small states and Transition rate(%) of Kazakhstan?
Your answer should be compact. -11.27. In the year 2008, what is the difference between the Transition rate(%) in Iceland and Transition rate(%) in Kazakhstan?
Offer a terse response. -0.37. What is the ratio of the Transition rate(%) of Small states in 2001 to that in 2002?
Make the answer very short. 0.98. What is the ratio of the Transition rate(%) of Kazakhstan in 2001 to that in 2002?
Make the answer very short. 1. What is the ratio of the Transition rate(%) in European Union in 2001 to that in 2003?
Your answer should be very brief. 1. What is the ratio of the Transition rate(%) in Small states in 2001 to that in 2003?
Your answer should be compact. 0.97. What is the ratio of the Transition rate(%) of European Union in 2001 to that in 2004?
Your answer should be compact. 1. What is the ratio of the Transition rate(%) of Small states in 2001 to that in 2004?
Offer a very short reply. 0.97. What is the ratio of the Transition rate(%) of Iceland in 2001 to that in 2004?
Offer a terse response. 1.01. What is the ratio of the Transition rate(%) in Kazakhstan in 2001 to that in 2004?
Offer a very short reply. 0.99. What is the ratio of the Transition rate(%) in European Union in 2001 to that in 2005?
Your response must be concise. 1. What is the ratio of the Transition rate(%) of Small states in 2001 to that in 2005?
Keep it short and to the point. 0.95. What is the ratio of the Transition rate(%) in Iceland in 2001 to that in 2005?
Make the answer very short. 1. What is the ratio of the Transition rate(%) in Small states in 2001 to that in 2007?
Ensure brevity in your answer.  0.95. What is the ratio of the Transition rate(%) of European Union in 2001 to that in 2008?
Your answer should be very brief. 1. What is the ratio of the Transition rate(%) in Small states in 2001 to that in 2008?
Offer a very short reply. 0.95. What is the ratio of the Transition rate(%) in Kazakhstan in 2001 to that in 2008?
Keep it short and to the point. 0.99. What is the ratio of the Transition rate(%) of Small states in 2002 to that in 2003?
Ensure brevity in your answer.  0.99. What is the ratio of the Transition rate(%) in Iceland in 2002 to that in 2003?
Keep it short and to the point. 1.01. What is the ratio of the Transition rate(%) of Kazakhstan in 2002 to that in 2003?
Your response must be concise. 1. What is the ratio of the Transition rate(%) in Small states in 2002 to that in 2004?
Make the answer very short. 0.98. What is the ratio of the Transition rate(%) in Iceland in 2002 to that in 2004?
Your answer should be compact. 1.01. What is the ratio of the Transition rate(%) of European Union in 2002 to that in 2005?
Your answer should be compact. 1. What is the ratio of the Transition rate(%) of Small states in 2002 to that in 2005?
Give a very brief answer. 0.97. What is the ratio of the Transition rate(%) of Kazakhstan in 2002 to that in 2005?
Give a very brief answer. 0.99. What is the ratio of the Transition rate(%) in Small states in 2002 to that in 2007?
Your response must be concise. 0.97. What is the ratio of the Transition rate(%) of Iceland in 2002 to that in 2007?
Provide a succinct answer. 1. What is the ratio of the Transition rate(%) of Small states in 2002 to that in 2008?
Ensure brevity in your answer.  0.97. What is the ratio of the Transition rate(%) in European Union in 2003 to that in 2004?
Ensure brevity in your answer.  1. What is the ratio of the Transition rate(%) in Small states in 2003 to that in 2004?
Your response must be concise. 0.99. What is the ratio of the Transition rate(%) of Small states in 2003 to that in 2005?
Make the answer very short. 0.98. What is the ratio of the Transition rate(%) in Small states in 2003 to that in 2007?
Your answer should be very brief. 0.98. What is the ratio of the Transition rate(%) in Kazakhstan in 2003 to that in 2007?
Your response must be concise. 0.99. What is the ratio of the Transition rate(%) of Small states in 2003 to that in 2008?
Offer a terse response. 0.98. What is the ratio of the Transition rate(%) in Iceland in 2003 to that in 2008?
Offer a terse response. 1. What is the ratio of the Transition rate(%) of Small states in 2004 to that in 2005?
Offer a very short reply. 0.98. What is the ratio of the Transition rate(%) in Iceland in 2004 to that in 2005?
Offer a very short reply. 0.99. What is the ratio of the Transition rate(%) of Small states in 2004 to that in 2007?
Your response must be concise. 0.98. What is the ratio of the Transition rate(%) of Iceland in 2004 to that in 2007?
Keep it short and to the point. 0.99. What is the ratio of the Transition rate(%) in Small states in 2004 to that in 2008?
Provide a short and direct response. 0.99. What is the ratio of the Transition rate(%) of Small states in 2005 to that in 2007?
Ensure brevity in your answer.  1. What is the ratio of the Transition rate(%) in Iceland in 2005 to that in 2007?
Make the answer very short. 1. What is the ratio of the Transition rate(%) of Small states in 2005 to that in 2008?
Offer a very short reply. 1. What is the ratio of the Transition rate(%) of Iceland in 2005 to that in 2008?
Ensure brevity in your answer.  1. What is the ratio of the Transition rate(%) of European Union in 2007 to that in 2008?
Ensure brevity in your answer.  1. What is the difference between the highest and the second highest Transition rate(%) in European Union?
Give a very brief answer. 0. What is the difference between the highest and the second highest Transition rate(%) in Small states?
Ensure brevity in your answer.  0.16. What is the difference between the highest and the second highest Transition rate(%) of Kazakhstan?
Offer a very short reply. 0.05. What is the difference between the highest and the lowest Transition rate(%) of European Union?
Make the answer very short. 0.35. What is the difference between the highest and the lowest Transition rate(%) of Small states?
Your answer should be very brief. 4.65. What is the difference between the highest and the lowest Transition rate(%) of Iceland?
Your answer should be compact. 1.14. What is the difference between the highest and the lowest Transition rate(%) of Kazakhstan?
Your response must be concise. 0.77. 